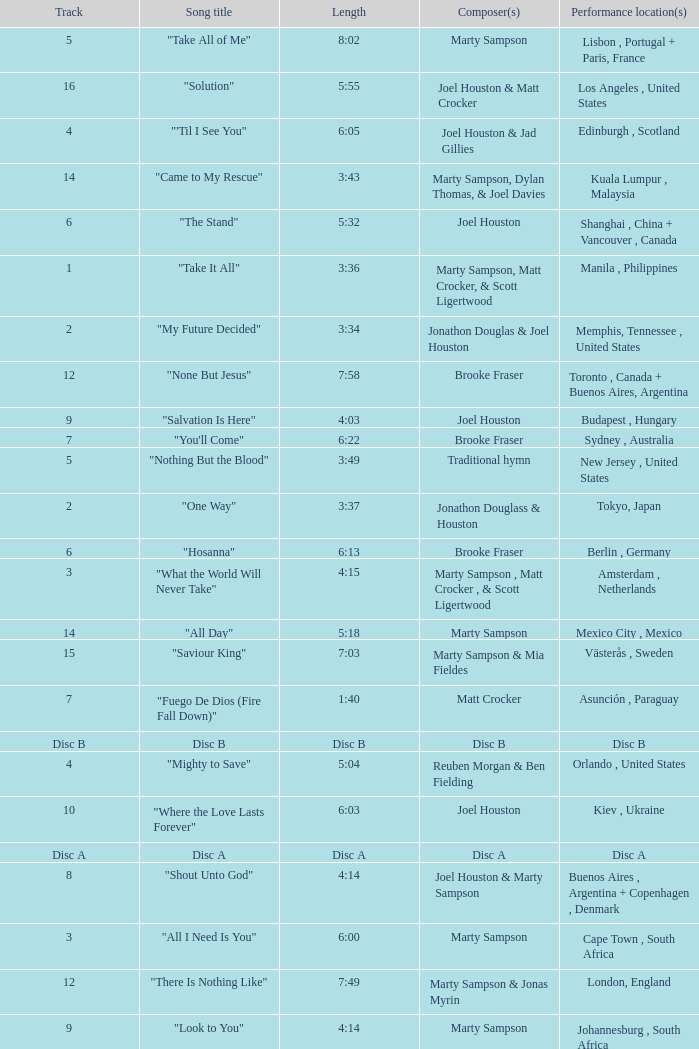What is the lengtho f track 16? 5:55. 